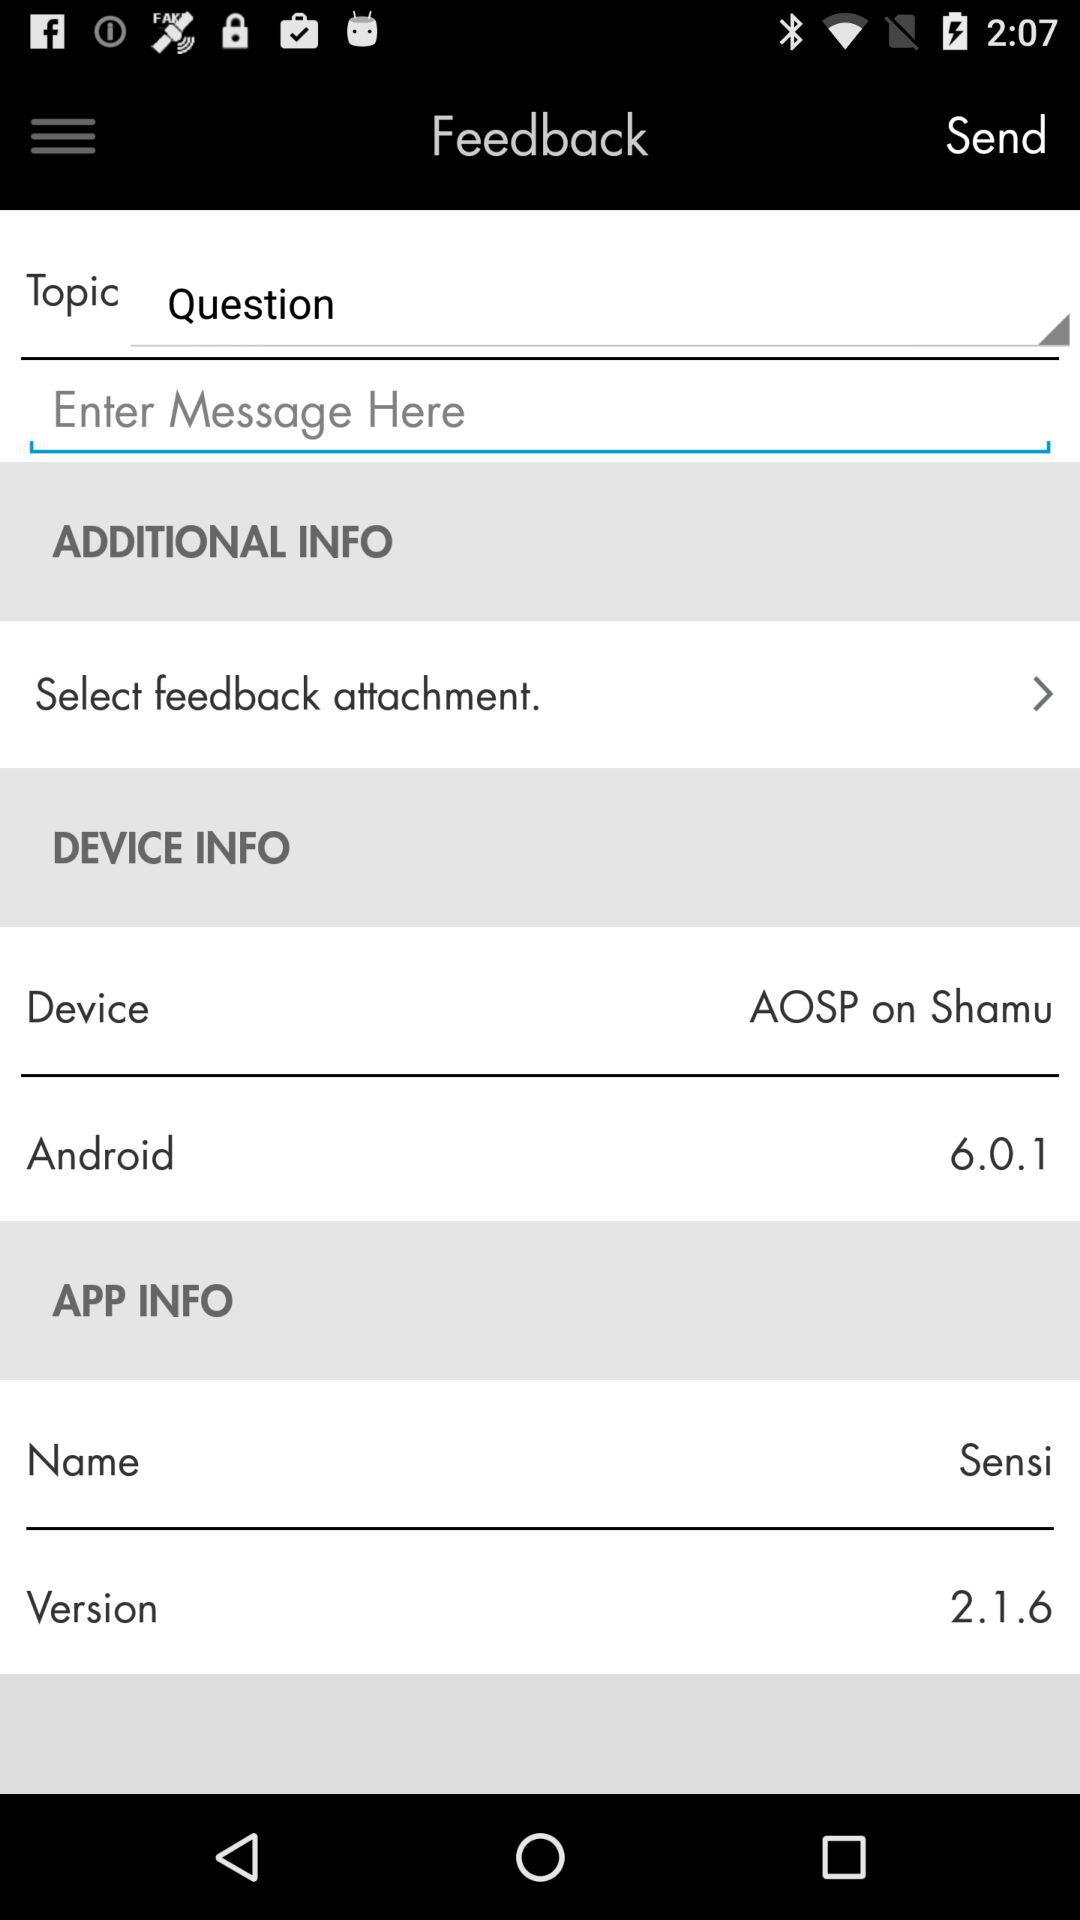What is the app name? The app name is "Sensi". 